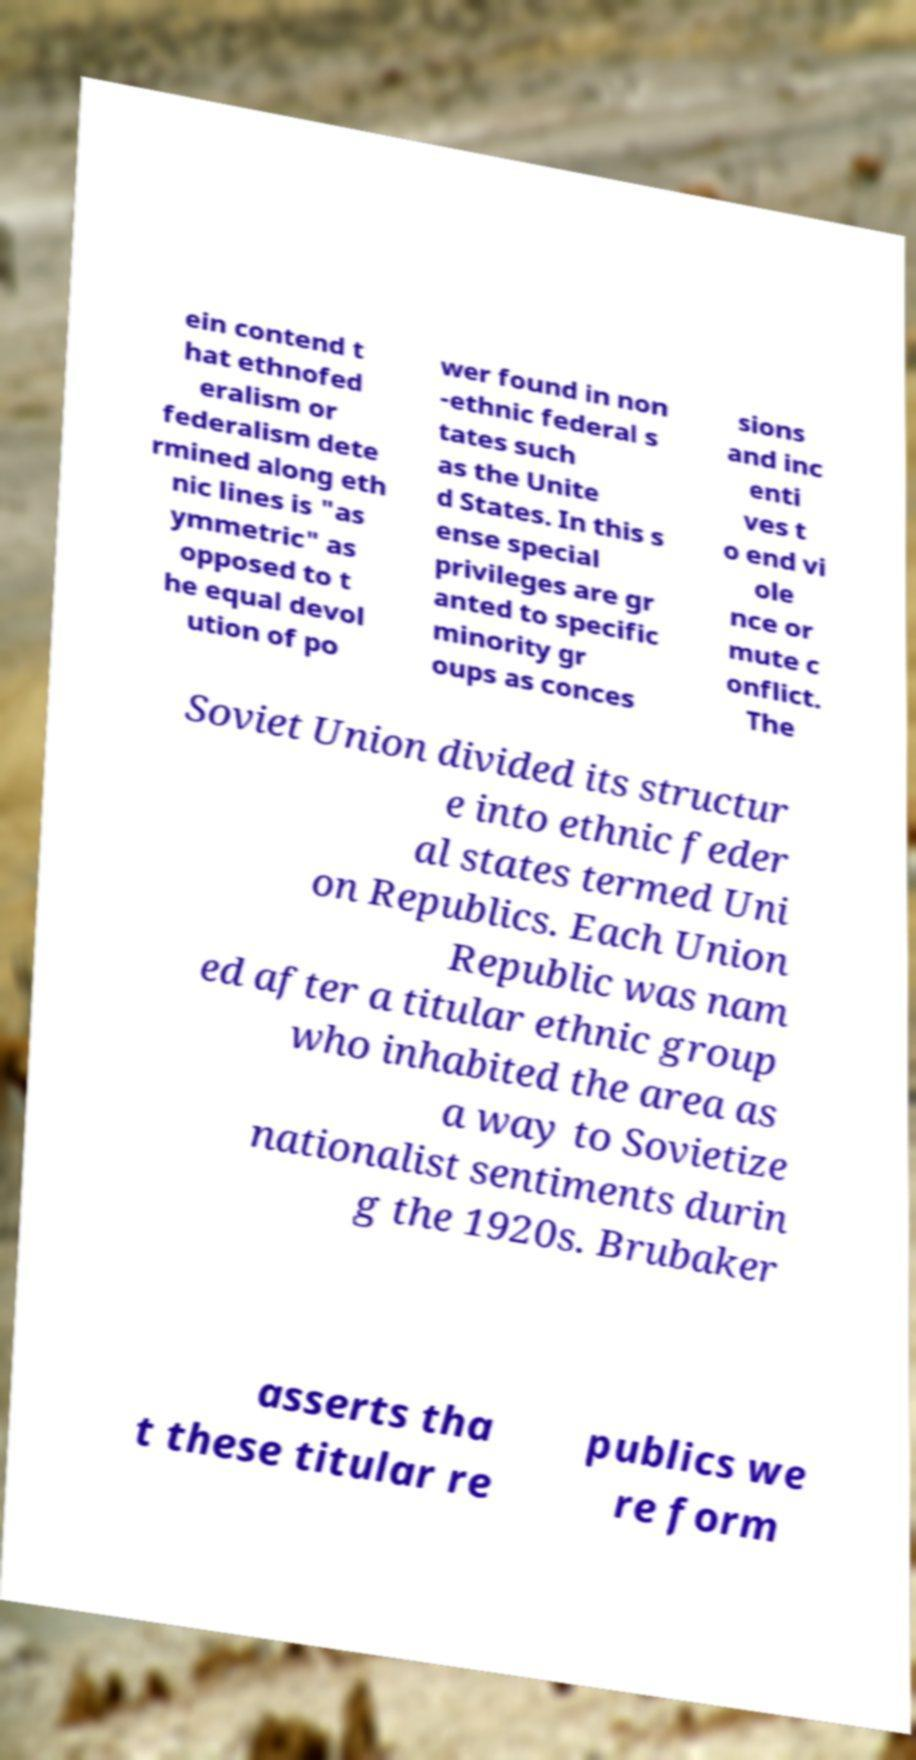Please identify and transcribe the text found in this image. ein contend t hat ethnofed eralism or federalism dete rmined along eth nic lines is "as ymmetric" as opposed to t he equal devol ution of po wer found in non -ethnic federal s tates such as the Unite d States. In this s ense special privileges are gr anted to specific minority gr oups as conces sions and inc enti ves t o end vi ole nce or mute c onflict. The Soviet Union divided its structur e into ethnic feder al states termed Uni on Republics. Each Union Republic was nam ed after a titular ethnic group who inhabited the area as a way to Sovietize nationalist sentiments durin g the 1920s. Brubaker asserts tha t these titular re publics we re form 